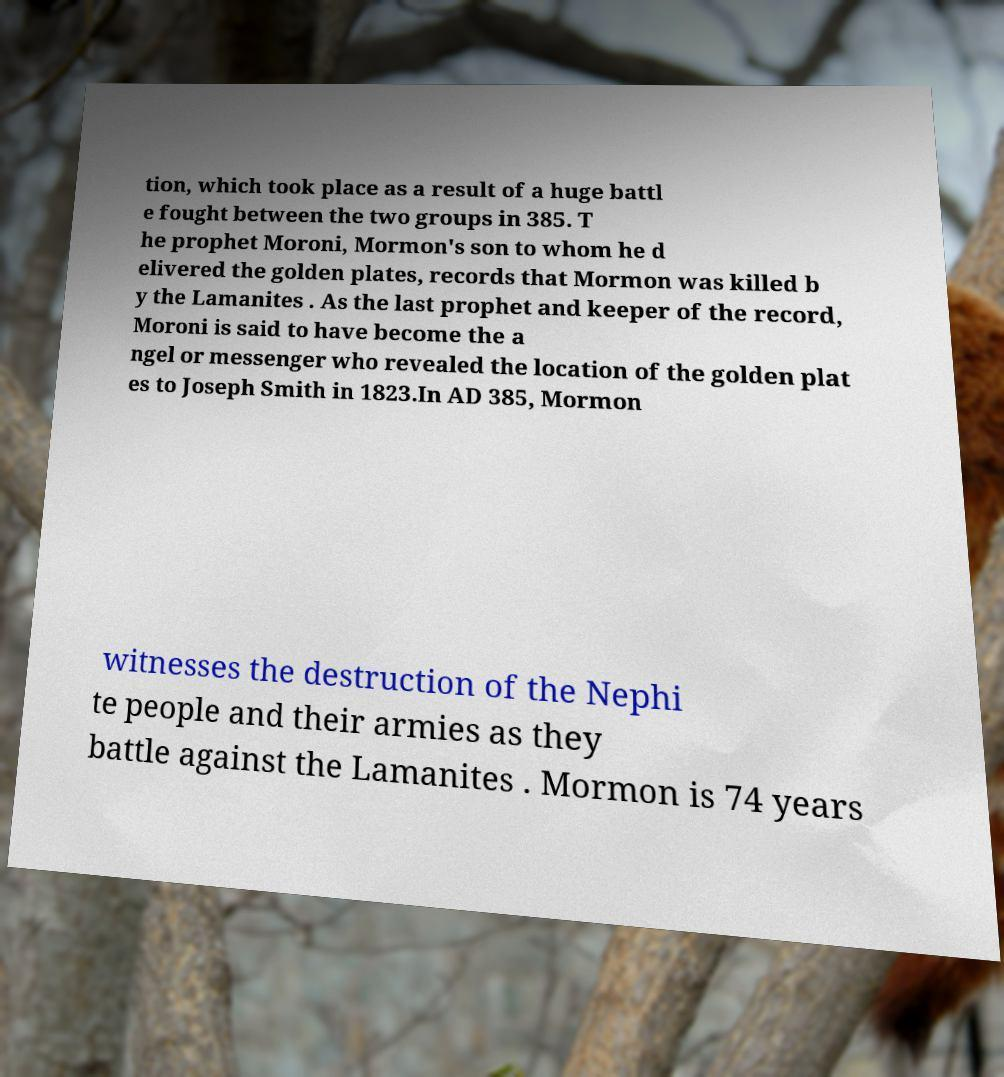Could you extract and type out the text from this image? tion, which took place as a result of a huge battl e fought between the two groups in 385. T he prophet Moroni, Mormon's son to whom he d elivered the golden plates, records that Mormon was killed b y the Lamanites . As the last prophet and keeper of the record, Moroni is said to have become the a ngel or messenger who revealed the location of the golden plat es to Joseph Smith in 1823.In AD 385, Mormon witnesses the destruction of the Nephi te people and their armies as they battle against the Lamanites . Mormon is 74 years 